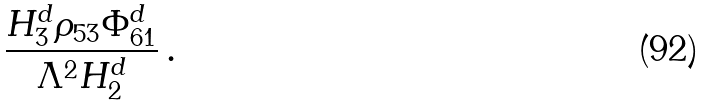Convert formula to latex. <formula><loc_0><loc_0><loc_500><loc_500>\frac { H _ { 3 } ^ { d } \rho _ { 5 3 } \Phi _ { 6 1 } ^ { d } } { \Lambda ^ { 2 } H _ { 2 } ^ { d } } \, .</formula> 